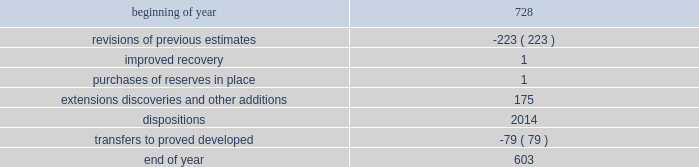During 2015 , 2014 and 2013 , netherland , sewell & associates , inc .
( "nsai" ) prepared a certification of the prior year's reserves for the alba field in e.g .
The nsai summary reports are filed as an exhibit to this annual report on form 10-k .
Members of the nsai team have multiple years of industry experience , having worked for large , international oil and gas companies before joining nsai .
The senior technical advisor has over 35 years of practical experience in petroleum geosciences , with over 15 years experience in the estimation and evaluation of reserves .
The second team member has over 10 years of practical experience in petroleum engineering , with over five years experience in the estimation and evaluation of reserves .
Both are registered professional engineers in the state of texas .
Ryder scott company ( "ryder scott" ) also performed audits of the prior years' reserves of several of our fields in 2015 , 2014 and 2013 .
Their summary reports are filed as exhibits to this annual report on form 10-k .
The team lead for ryder scott has over 20 years of industry experience , having worked for a major international oil and gas company before joining ryder scott .
He is a member of spe , where he served on the oil and gas reserves committee , and is a registered professional engineer in the state of texas .
Changes in proved undeveloped reserves as of december 31 , 2015 , 603 mmboe of proved undeveloped reserves were reported , a decrease of 125 mmboe from december 31 , 2014 .
The table shows changes in total proved undeveloped reserves for 2015 : ( mmboe ) .
The revisions to previous estimates were largely due to a result of reductions to our capital development program which deferred proved undeveloped reserves beyond the 5-year plan .
A total of 139 mmboe was booked as extensions , discoveries or other additions and revisions due to the application of reliable technology .
Technologies included statistical analysis of production performance , decline curve analysis , pressure and rate transient analysis , reservoir simulation and volumetric analysis .
The observed statistical nature of production performance coupled with highly certain reservoir continuity or quality within the reliable technology areas and sufficient proved developed locations establish the reasonable certainty criteria required for booking proved reserves .
Transfers from proved undeveloped to proved developed reserves included 47 mmboe in the eagle ford , 14 mmboe in the bakken and 5 mmboe in the oklahoma resource basins due to development drilling and completions .
Costs incurred in 2015 , 2014 and 2013 relating to the development of proved undeveloped reserves were $ 1415 million , $ 3149 million and $ 2536 million .
Projects can remain in proved undeveloped reserves for extended periods in certain situations such as large development projects which take more than five years to complete , or the timing of when additional gas compression is needed .
Of the 603 mmboe of proved undeveloped reserves at december 31 , 2015 , 26% ( 26 % ) of the volume is associated with projects that have been included in proved reserves for more than five years .
The majority of this volume is related to a compression project in e.g .
That was sanctioned by our board of directors in 2004 .
During 2012 , the compression project received the approval of the e.g .
Government , fabrication of the new platform began in 2013 and installation of the platform at the alba field occurred in january 2016 .
Commissioning is currently underway , with first production expected by mid-2016 .
Proved undeveloped reserves for the north gialo development , located in the libyan sahara desert , were booked for the first time in 2010 .
This development is being executed by the operator and encompasses a multi-year drilling program including the design , fabrication and installation of extensive liquid handling and gas recycling facilities .
Anecdotal evidence from similar development projects in the region leads to an expected project execution time frame of more than five years from the time the reserves were initially booked .
Interruptions associated with the civil and political unrest have also extended the project duration .
Operations were interrupted in mid-2013 as a result of the shutdown of the es sider crude oil terminal , and although temporarily re-opened during the second half of 2014 , production remains shut-in through early 2016 .
The operator is committed to the project 2019s completion and continues to assign resources in order to execute the project .
Our conversion rate for proved undeveloped reserves to proved developed reserves for 2015 was 11% ( 11 % ) .
However , excluding the aforementioned long-term projects in e.g .
And libya , our 2015 conversion rate would be 15% ( 15 % ) .
Furthermore , our .
What were total transfers from proved undeveloped to proved developed reserves in mmboe in the eagle ford and in the bakken ? 
Computations: (47 + 14)
Answer: 61.0. 